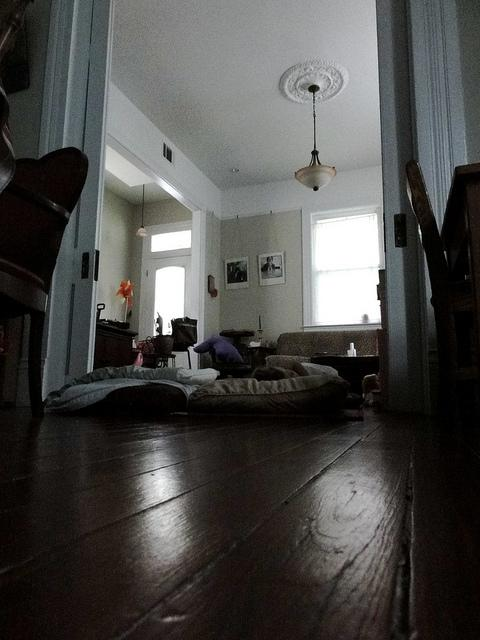What is the highest object in the room? Please explain your reasoning. hanging light. The light that is hanging from the ceiling. 